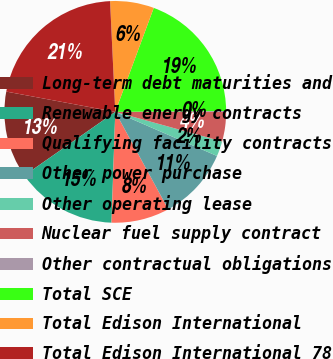Convert chart to OTSL. <chart><loc_0><loc_0><loc_500><loc_500><pie_chart><fcel>Long-term debt maturities and<fcel>Renewable energy contracts<fcel>Qualifying facility contracts<fcel>Other power purchase<fcel>Other operating lease<fcel>Nuclear fuel supply contract<fcel>Other contractual obligations<fcel>Total SCE<fcel>Total Edison International<fcel>Total Edison International 78<nl><fcel>12.65%<fcel>14.74%<fcel>8.47%<fcel>10.56%<fcel>2.21%<fcel>4.3%<fcel>0.13%<fcel>19.23%<fcel>6.39%<fcel>21.32%<nl></chart> 